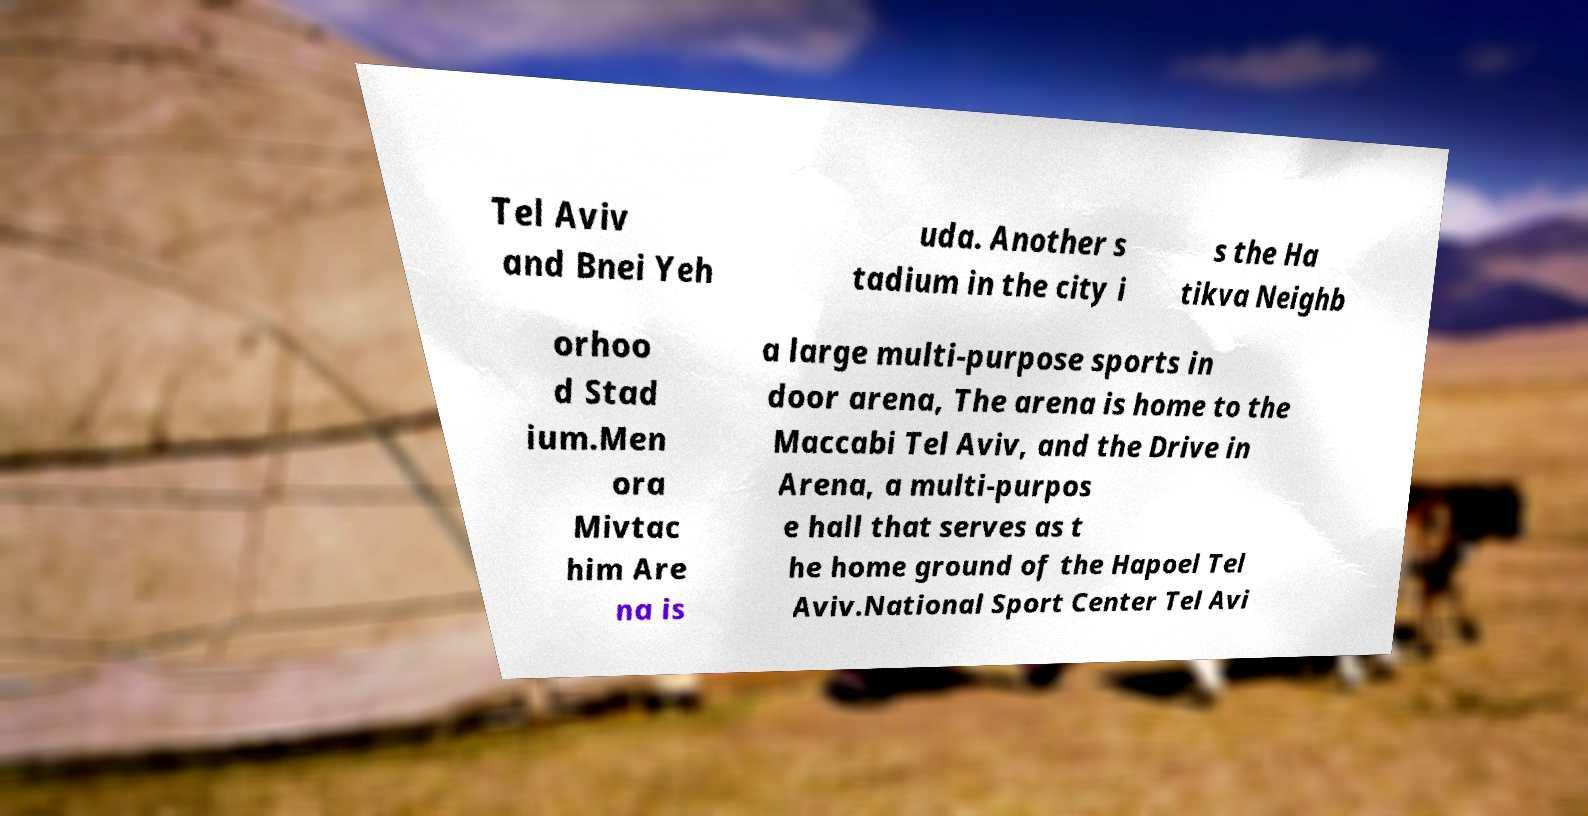Please read and relay the text visible in this image. What does it say? Tel Aviv and Bnei Yeh uda. Another s tadium in the city i s the Ha tikva Neighb orhoo d Stad ium.Men ora Mivtac him Are na is a large multi-purpose sports in door arena, The arena is home to the Maccabi Tel Aviv, and the Drive in Arena, a multi-purpos e hall that serves as t he home ground of the Hapoel Tel Aviv.National Sport Center Tel Avi 